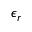Convert formula to latex. <formula><loc_0><loc_0><loc_500><loc_500>\epsilon _ { r }</formula> 